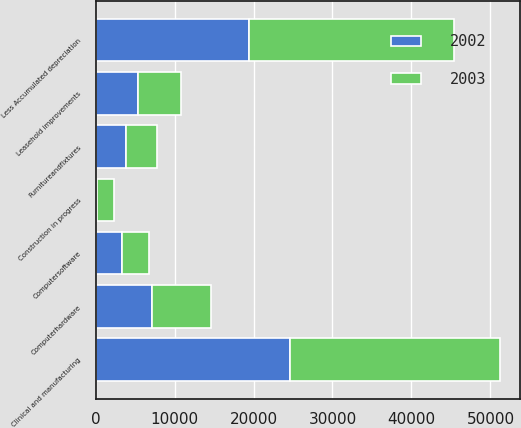Convert chart. <chart><loc_0><loc_0><loc_500><loc_500><stacked_bar_chart><ecel><fcel>Clinical and manufacturing<fcel>Computerhardware<fcel>Computersoftware<fcel>Furnitureandfixtures<fcel>Leasehold improvements<fcel>Construction in progress<fcel>Less Accumulated depreciation<nl><fcel>2003<fcel>26558<fcel>7471<fcel>3413<fcel>3961<fcel>5522<fcel>2133<fcel>25937<nl><fcel>2002<fcel>24662<fcel>7130<fcel>3350<fcel>3813<fcel>5321<fcel>191<fcel>19389<nl></chart> 